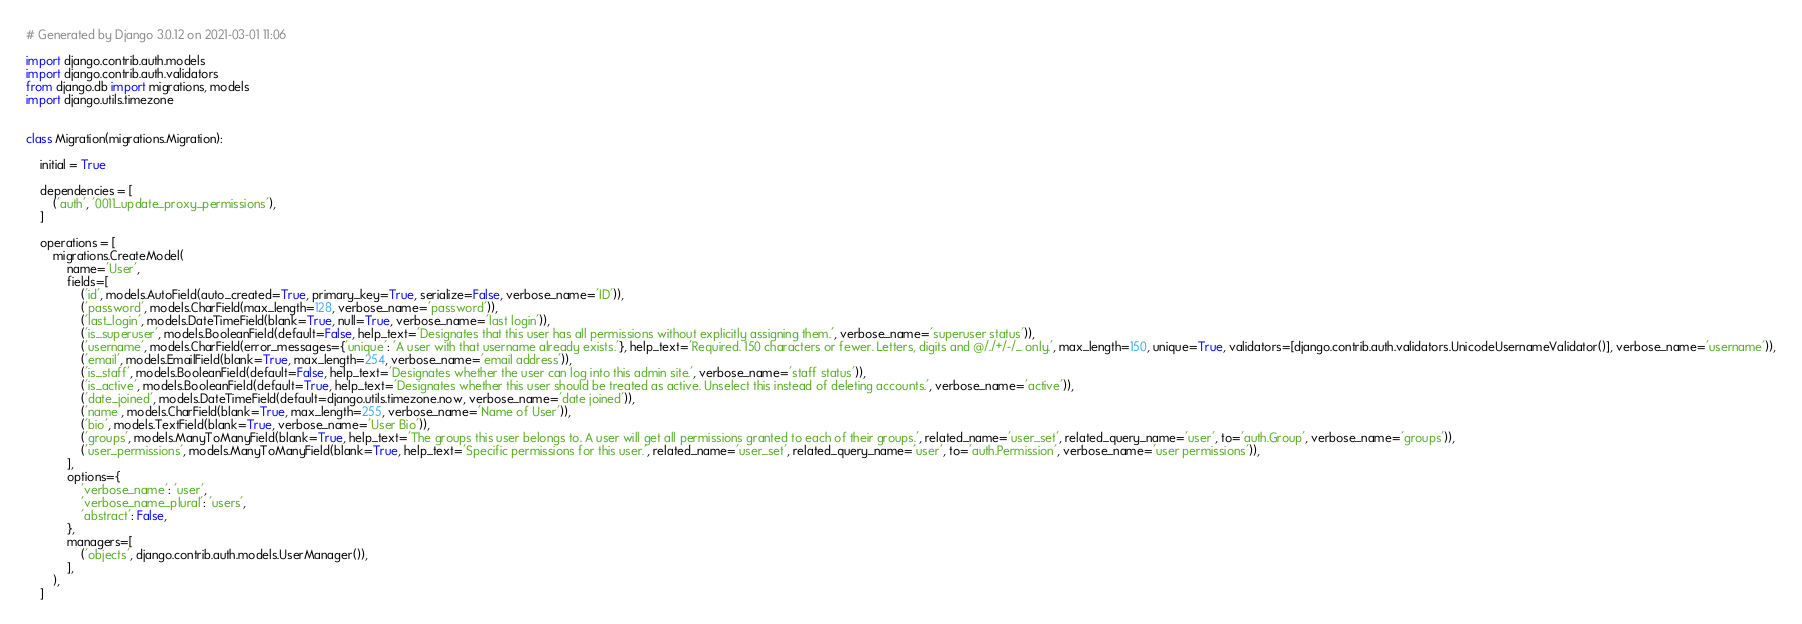<code> <loc_0><loc_0><loc_500><loc_500><_Python_># Generated by Django 3.0.12 on 2021-03-01 11:06

import django.contrib.auth.models
import django.contrib.auth.validators
from django.db import migrations, models
import django.utils.timezone


class Migration(migrations.Migration):

    initial = True

    dependencies = [
        ('auth', '0011_update_proxy_permissions'),
    ]

    operations = [
        migrations.CreateModel(
            name='User',
            fields=[
                ('id', models.AutoField(auto_created=True, primary_key=True, serialize=False, verbose_name='ID')),
                ('password', models.CharField(max_length=128, verbose_name='password')),
                ('last_login', models.DateTimeField(blank=True, null=True, verbose_name='last login')),
                ('is_superuser', models.BooleanField(default=False, help_text='Designates that this user has all permissions without explicitly assigning them.', verbose_name='superuser status')),
                ('username', models.CharField(error_messages={'unique': 'A user with that username already exists.'}, help_text='Required. 150 characters or fewer. Letters, digits and @/./+/-/_ only.', max_length=150, unique=True, validators=[django.contrib.auth.validators.UnicodeUsernameValidator()], verbose_name='username')),
                ('email', models.EmailField(blank=True, max_length=254, verbose_name='email address')),
                ('is_staff', models.BooleanField(default=False, help_text='Designates whether the user can log into this admin site.', verbose_name='staff status')),
                ('is_active', models.BooleanField(default=True, help_text='Designates whether this user should be treated as active. Unselect this instead of deleting accounts.', verbose_name='active')),
                ('date_joined', models.DateTimeField(default=django.utils.timezone.now, verbose_name='date joined')),
                ('name', models.CharField(blank=True, max_length=255, verbose_name='Name of User')),
                ('bio', models.TextField(blank=True, verbose_name='User Bio')),
                ('groups', models.ManyToManyField(blank=True, help_text='The groups this user belongs to. A user will get all permissions granted to each of their groups.', related_name='user_set', related_query_name='user', to='auth.Group', verbose_name='groups')),
                ('user_permissions', models.ManyToManyField(blank=True, help_text='Specific permissions for this user.', related_name='user_set', related_query_name='user', to='auth.Permission', verbose_name='user permissions')),
            ],
            options={
                'verbose_name': 'user',
                'verbose_name_plural': 'users',
                'abstract': False,
            },
            managers=[
                ('objects', django.contrib.auth.models.UserManager()),
            ],
        ),
    ]
</code> 